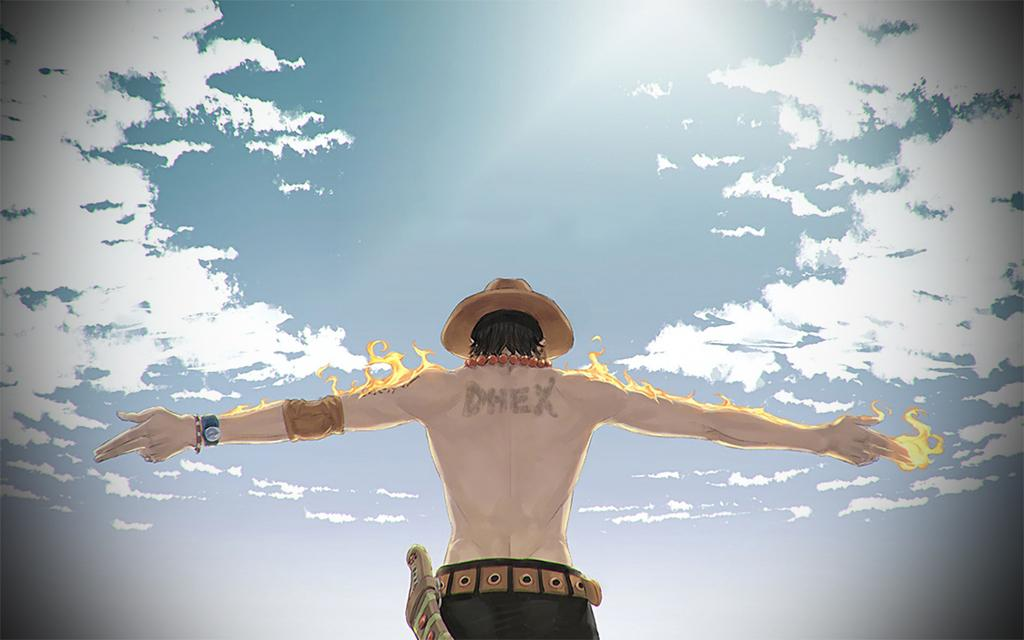What type of image is in the picture? There is an animated image of a man in the picture. What is the man doing in the image? The man is standing with both hands raised. What is happening to the man's hands? There is fire on the man's hands. What can be seen in the background of the image? The sky is visible at the top of the image. Where is the girl spreading jam on the dock in the image? There is no girl spreading jam on a dock in the image; it features an animated man with fire on his hands. 